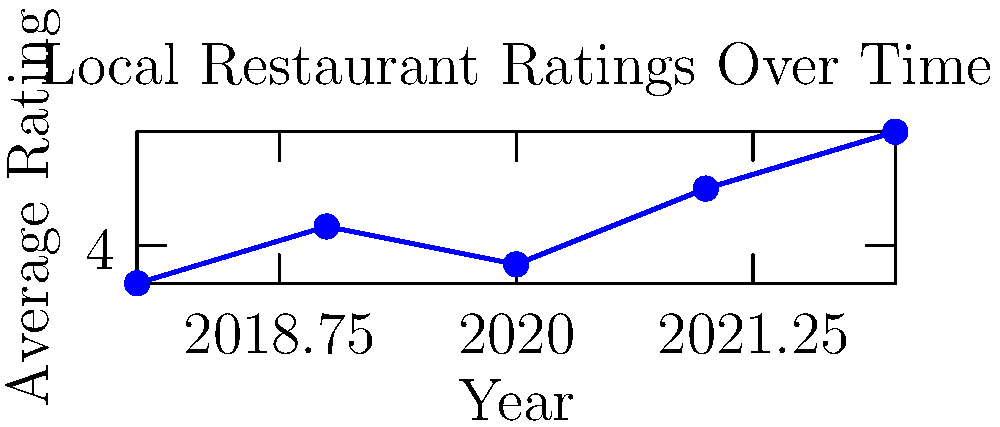Based on the line graph showing the growth in local restaurant ratings over time, what was the average increase in ratings per year from 2018 to 2022? To calculate the average increase in ratings per year:

1. Calculate the total increase from 2018 to 2022:
   Final rating (2022) - Initial rating (2018) = $4.6 - 3.8 = 0.8$

2. Determine the number of years:
   2022 - 2018 = 4 years

3. Calculate the average increase per year:
   Total increase / Number of years = $0.8 / 4 = 0.2$

Therefore, the average increase in ratings per year from 2018 to 2022 was 0.2.
Answer: 0.2 